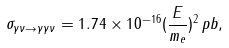Convert formula to latex. <formula><loc_0><loc_0><loc_500><loc_500>\sigma _ { \gamma \nu \rightarrow \gamma \gamma \nu } = 1 . 7 4 \times 1 0 ^ { - 1 6 } ( \frac { E } { m _ { e } } ) ^ { 2 } \, p b ,</formula> 